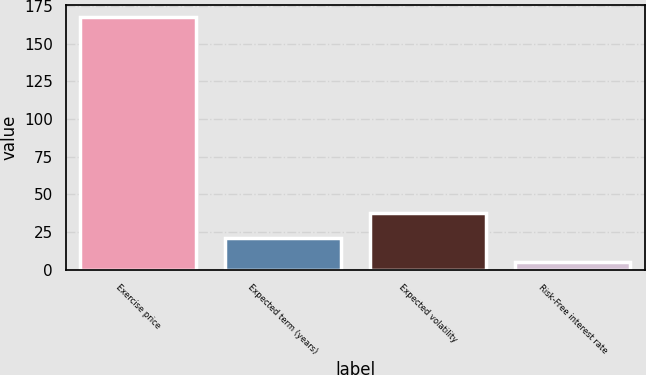<chart> <loc_0><loc_0><loc_500><loc_500><bar_chart><fcel>Exercise price<fcel>Expected term (years)<fcel>Expected volatility<fcel>Risk-Free interest rate<nl><fcel>167.76<fcel>21.1<fcel>37.4<fcel>4.8<nl></chart> 